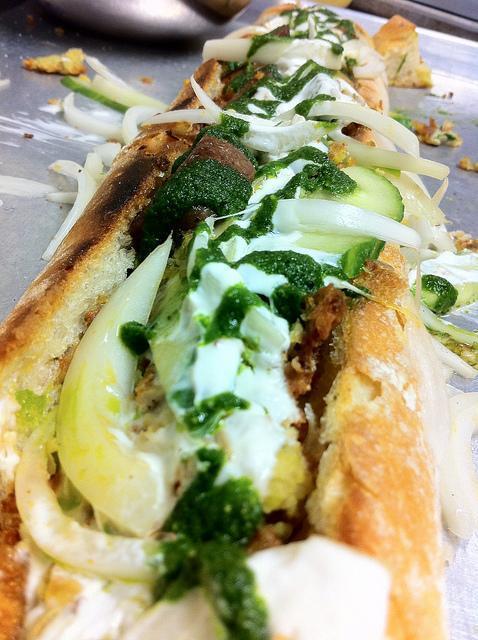How many sandwiches are in the photo?
Give a very brief answer. 1. 